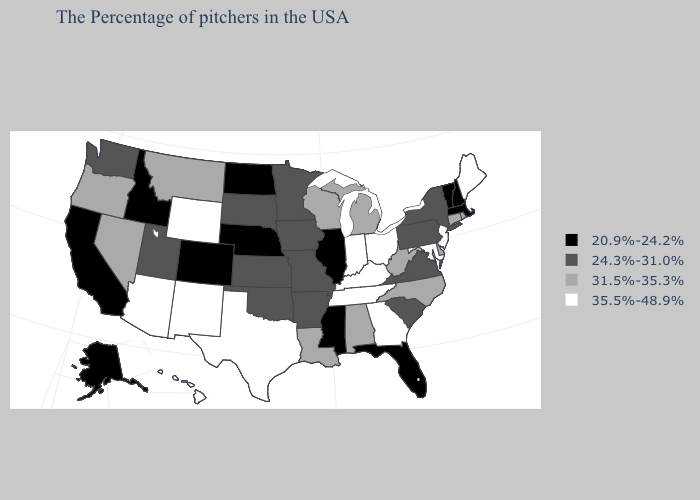Name the states that have a value in the range 24.3%-31.0%?
Concise answer only. New York, Pennsylvania, Virginia, South Carolina, Missouri, Arkansas, Minnesota, Iowa, Kansas, Oklahoma, South Dakota, Utah, Washington. Does Washington have the highest value in the USA?
Give a very brief answer. No. Does New Jersey have a higher value than Maryland?
Be succinct. No. Which states have the lowest value in the USA?
Keep it brief. Massachusetts, New Hampshire, Vermont, Florida, Illinois, Mississippi, Nebraska, North Dakota, Colorado, Idaho, California, Alaska. Does Alaska have the lowest value in the USA?
Give a very brief answer. Yes. What is the lowest value in states that border Maine?
Write a very short answer. 20.9%-24.2%. What is the value of Iowa?
Be succinct. 24.3%-31.0%. Does West Virginia have a higher value than Maryland?
Write a very short answer. No. What is the value of Utah?
Quick response, please. 24.3%-31.0%. What is the value of Alaska?
Keep it brief. 20.9%-24.2%. What is the highest value in the USA?
Keep it brief. 35.5%-48.9%. Does the map have missing data?
Write a very short answer. No. Does the map have missing data?
Concise answer only. No. Which states have the highest value in the USA?
Answer briefly. Maine, New Jersey, Maryland, Ohio, Georgia, Kentucky, Indiana, Tennessee, Texas, Wyoming, New Mexico, Arizona, Hawaii. Name the states that have a value in the range 31.5%-35.3%?
Quick response, please. Rhode Island, Connecticut, Delaware, North Carolina, West Virginia, Michigan, Alabama, Wisconsin, Louisiana, Montana, Nevada, Oregon. 